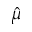Convert formula to latex. <formula><loc_0><loc_0><loc_500><loc_500>\hat { \mu }</formula> 